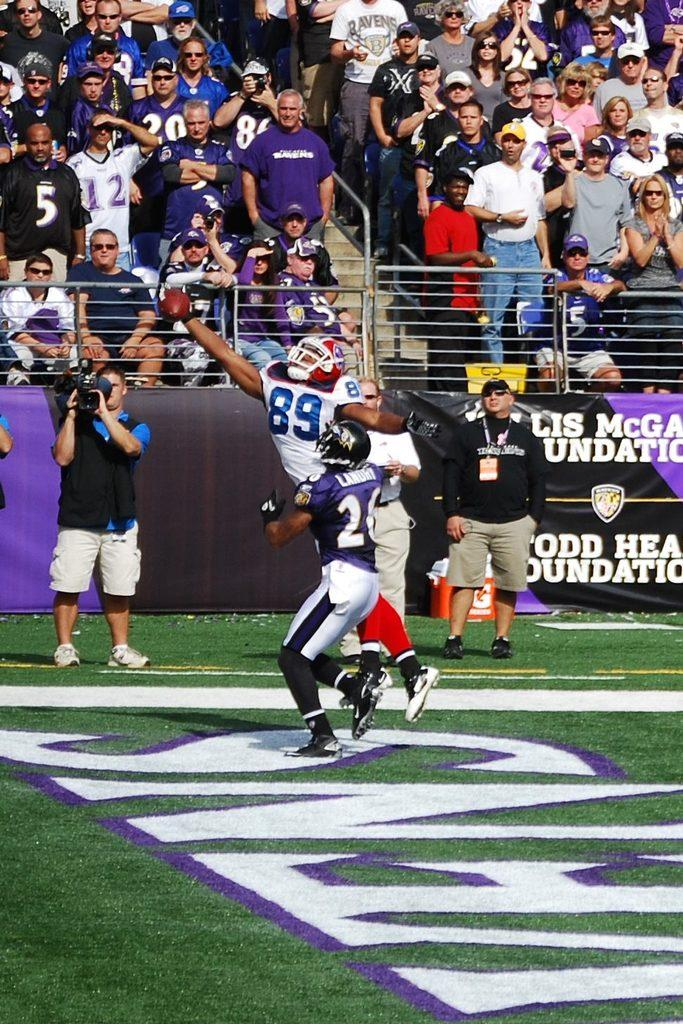What is happening at the top of the image? There are persons standing on the stairs at the top of the image. What is happening at the bottom of the image? There are persons in the ground at the bottom of the image. Can you describe the activity of one person at the bottom of the image? One person at the bottom of the image is holding a camera in his hands. What type of acoustics can be heard from the clam at the top of the image? There is no clam present in the image, and therefore no acoustics can be heard from it. Is there a crown visible on any of the persons in the image? There is no crown visible on any of the persons in the image. 